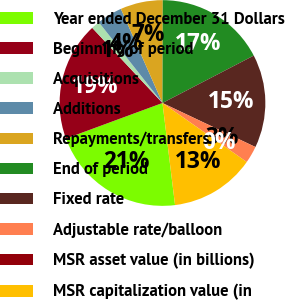<chart> <loc_0><loc_0><loc_500><loc_500><pie_chart><fcel>Year ended December 31 Dollars<fcel>Beginning of period<fcel>Acquisitions<fcel>Additions<fcel>Repayments/transfers<fcel>End of period<fcel>Fixed rate<fcel>Adjustable rate/balloon<fcel>MSR asset value (in billions)<fcel>MSR capitalization value (in<nl><fcel>21.33%<fcel>18.66%<fcel>1.34%<fcel>4.0%<fcel>6.67%<fcel>17.33%<fcel>14.66%<fcel>2.67%<fcel>0.01%<fcel>13.33%<nl></chart> 